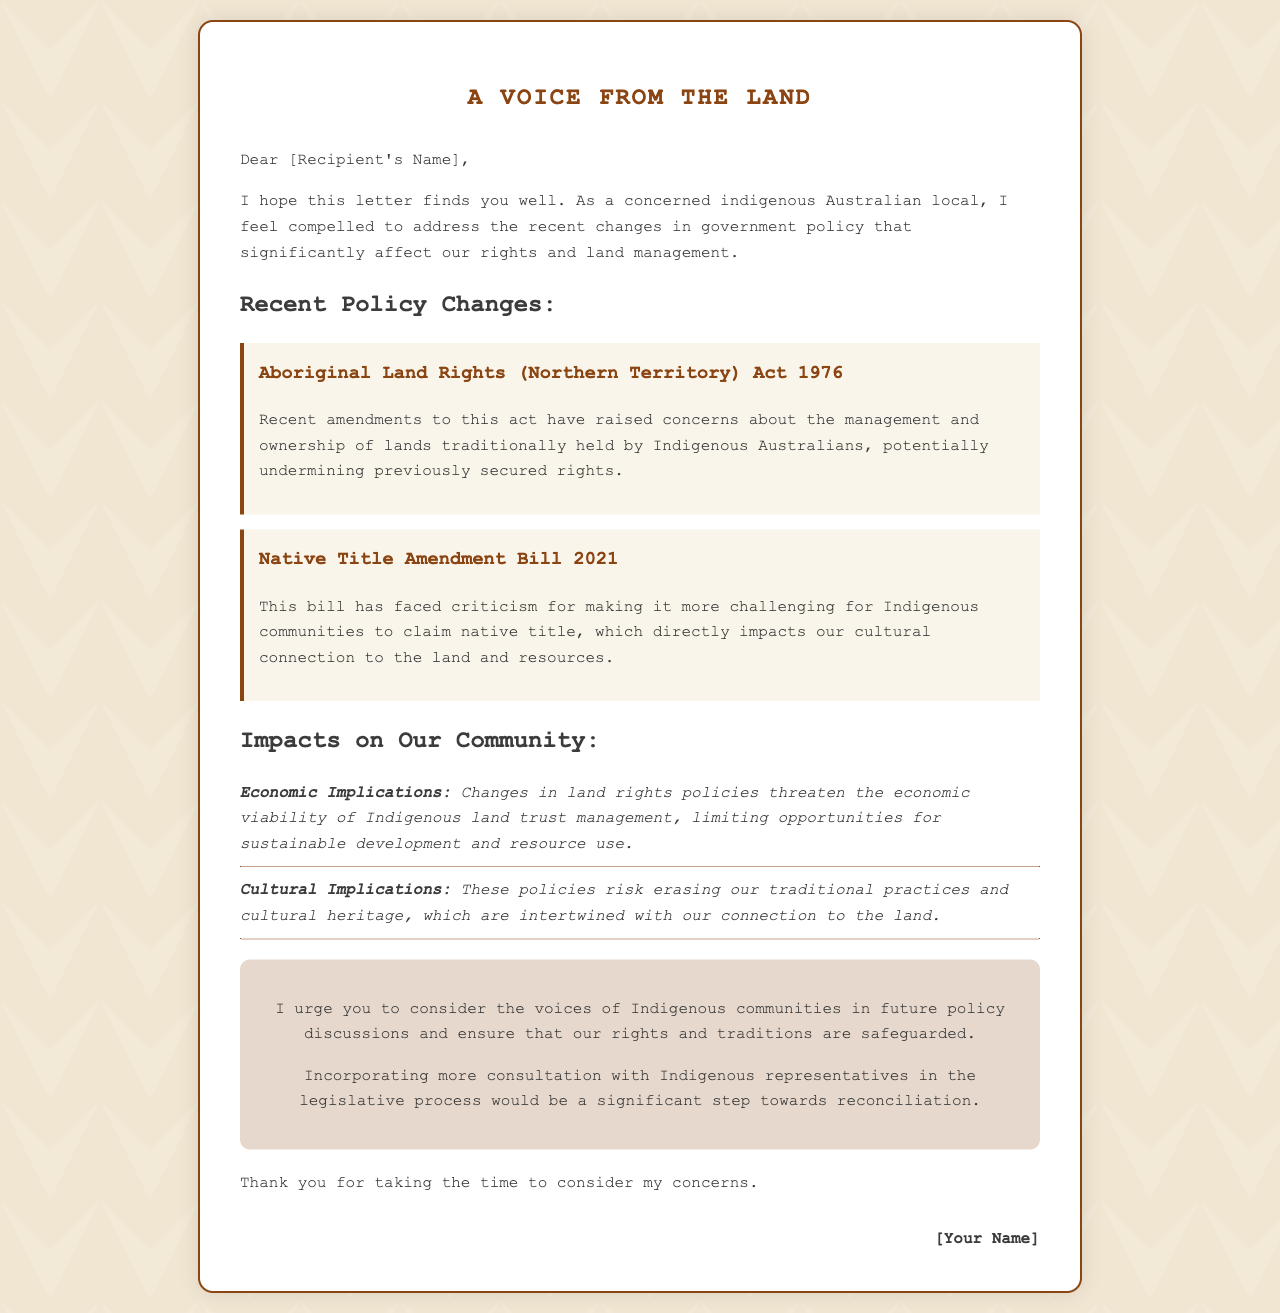what is the primary subject of the letter? The letter addresses recent changes in government policy affecting indigenous rights and land management.
Answer: changes in government policy who is the intended recipient of the letter? The letter is addressed to a specific person, indicated as [Recipient's Name].
Answer: [Recipient's Name] what act is mentioned regarding Aboriginal land rights? The letter references the Aboriginal Land Rights (Northern Territory) Act 1976.
Answer: Aboriginal Land Rights (Northern Territory) Act 1976 what bill is criticized for making native title claims challenging? The Native Title Amendment Bill 2021 is criticized for its impact on native title claims.
Answer: Native Title Amendment Bill 2021 what are the economic implications of the policy changes? The changes threaten the economic viability of Indigenous land trust management.
Answer: economic viability what does the letter urge regarding Indigenous community voices? The letter urges more consultation with Indigenous representatives in policymaking.
Answer: more consultation how many main sections does the letter have? The letter contains four main sections: introduction, recent policy changes, impacts on the community, and call to action.
Answer: four what is the tone of the call-to-action section? The call-to-action section encourages positive change and inclusion of Indigenous voices.
Answer: encourages positive change who is signing off the letter? The letter is signed off by [Your Name].
Answer: [Your Name] 